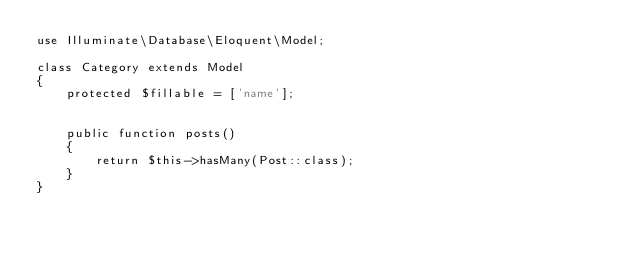<code> <loc_0><loc_0><loc_500><loc_500><_PHP_>use Illuminate\Database\Eloquent\Model;

class Category extends Model
{
    protected $fillable = ['name'];


    public function posts()
    {
        return $this->hasMany(Post::class);
    }
}</code> 